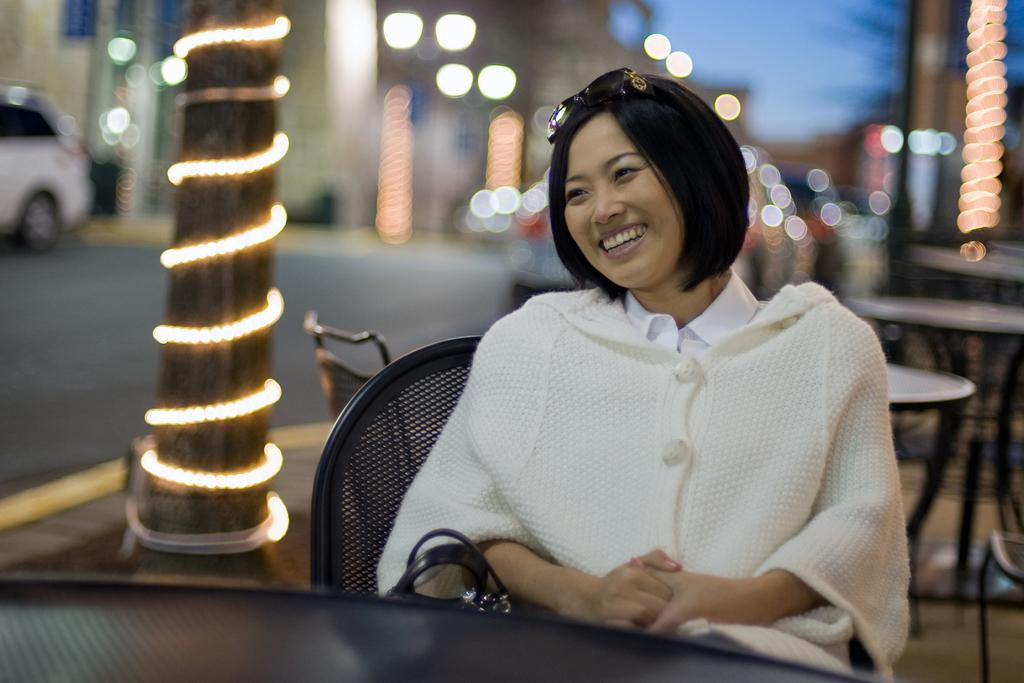Who is in the image? There is a woman in the image. What is the woman doing in the image? The woman is smiling in the image. What is the woman sitting on in the image? The woman is sitting in a chair in the image. Where is the chair located in relation to the table? The chair is in front of a table in the image. What can be seen in the background of the image? There is a pillar decorated with lights and buildings visible in the background of the image. What type of argument is the woman having with the shirt in the image? There is no shirt or argument present in the image; it features a woman sitting in a chair and smiling. 